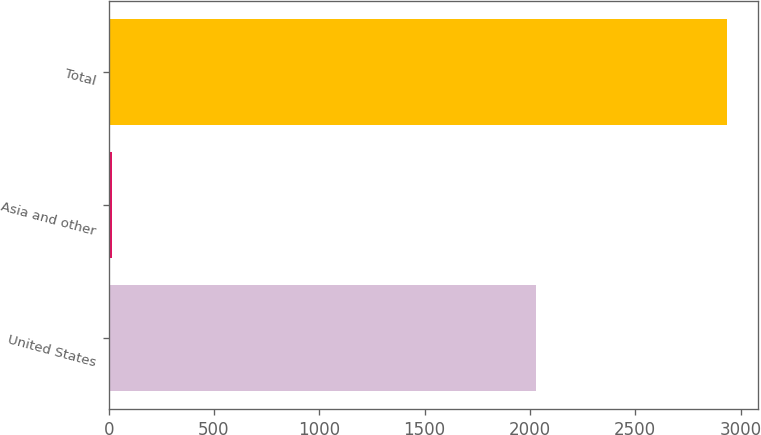<chart> <loc_0><loc_0><loc_500><loc_500><bar_chart><fcel>United States<fcel>Asia and other<fcel>Total<nl><fcel>2029<fcel>17<fcel>2936<nl></chart> 